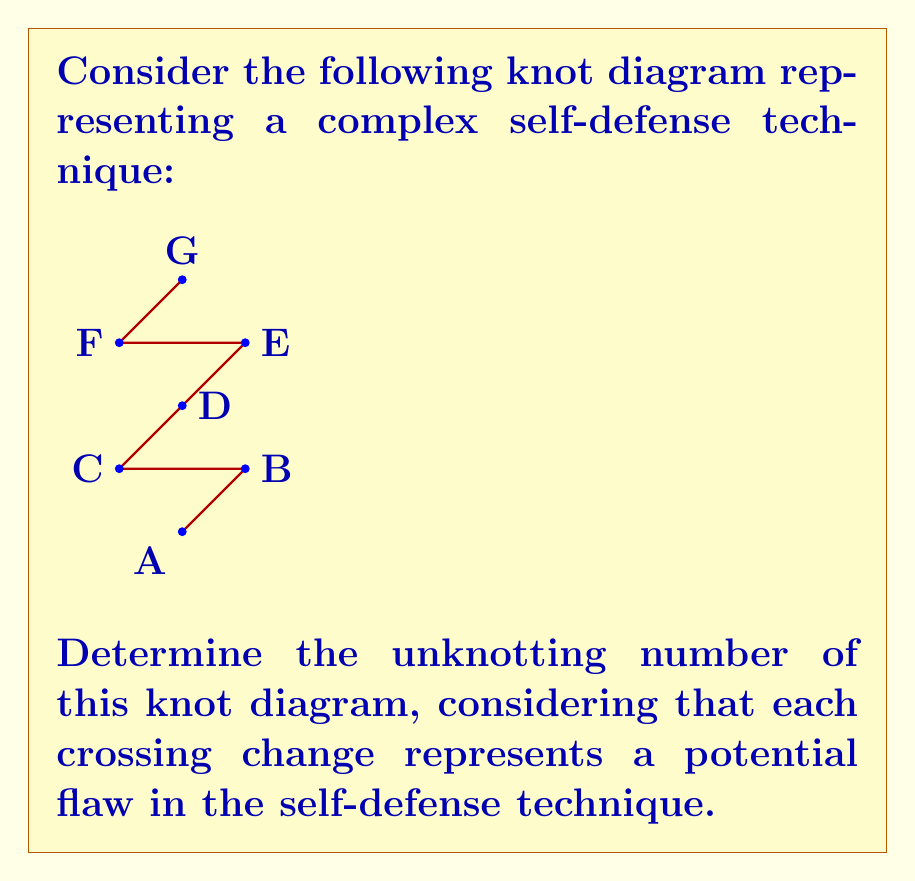Help me with this question. To determine the unknotting number of this knot diagram, we need to analyze the crossings and find the minimum number of crossing changes required to transform it into the unknot (trivial knot). Let's approach this step-by-step:

1) First, we identify the crossings in the diagram. There are 3 crossings: at points B, D, and F.

2) We need to consider all possible combinations of crossing changes to find the minimum number required to unknot the diagram.

3) Let's start by changing the crossing at point D:
   - This creates a loop that can be easily removed, leaving only one crossing at point F.
   - Changing this last crossing at F results in the unknot.

4) We can verify that changing only one crossing (either B or F) does not result in the unknot.

5) Therefore, we have found a sequence of two crossing changes that unknots the diagram:
   a) Change the crossing at D
   b) Change the crossing at F

6) We can prove that this is the minimum number of changes required:
   - Changing only one crossing always leaves at least one non-trivial crossing.
   - We found a solution with two changes.
   - Therefore, the unknotting number cannot be less than 2.

The unknotting number, in this case, represents the minimum number of flaws or weaknesses in the self-defense technique that need to be addressed to make it effective. This aligns with the skeptical perspective on complex self-defense programs, suggesting that even seemingly intricate techniques may have fundamental issues that need correction.
Answer: 2 